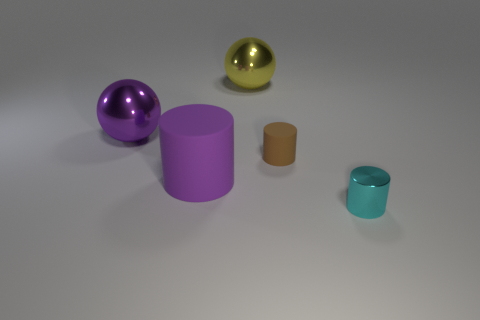There is a large matte cylinder that is to the left of the brown object; what number of small brown rubber things are to the right of it?
Offer a very short reply. 1. There is a large rubber cylinder; is its color the same as the large shiny sphere left of the big yellow thing?
Provide a short and direct response. Yes. How many large purple objects are the same shape as the brown thing?
Make the answer very short. 1. What is the big purple object that is in front of the purple metal object made of?
Offer a very short reply. Rubber. Do the purple object left of the large purple cylinder and the large yellow thing have the same shape?
Your response must be concise. Yes. Are there any cyan cylinders of the same size as the yellow shiny object?
Your answer should be compact. No. Does the brown object have the same shape as the object that is in front of the large purple cylinder?
Your answer should be compact. Yes. What shape is the big object that is the same color as the big cylinder?
Ensure brevity in your answer.  Sphere. Is the number of cyan metallic objects left of the yellow thing less than the number of tiny metal cylinders?
Offer a terse response. Yes. Is the small brown matte thing the same shape as the cyan object?
Provide a short and direct response. Yes. 